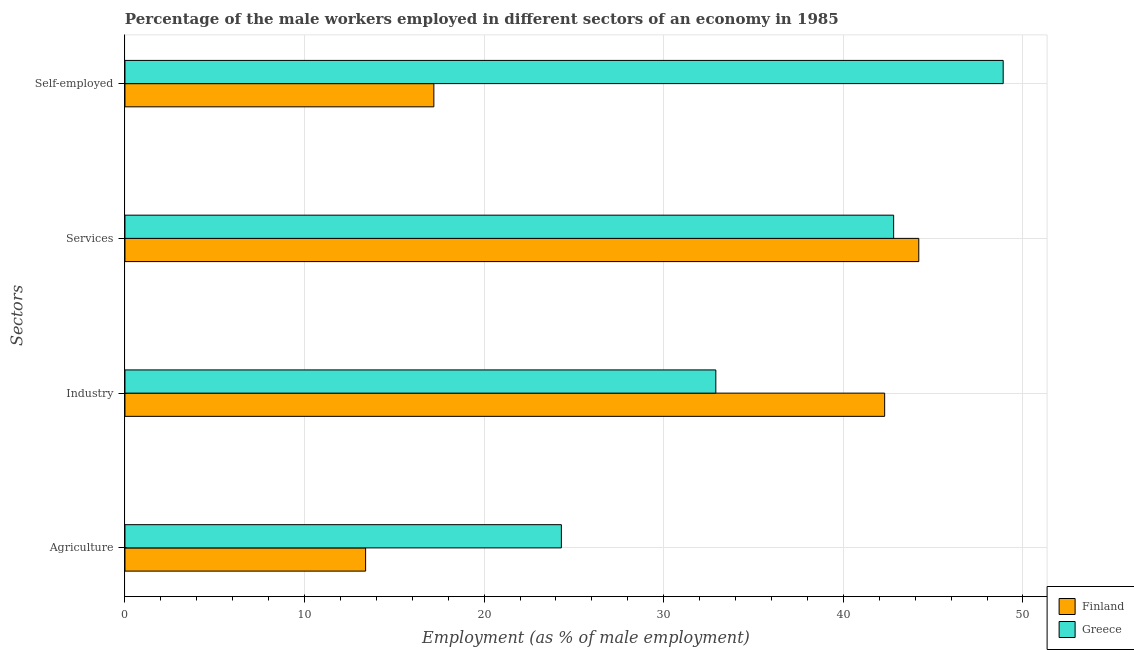How many different coloured bars are there?
Give a very brief answer. 2. Are the number of bars per tick equal to the number of legend labels?
Your answer should be very brief. Yes. Are the number of bars on each tick of the Y-axis equal?
Your response must be concise. Yes. How many bars are there on the 2nd tick from the bottom?
Your response must be concise. 2. What is the label of the 2nd group of bars from the top?
Keep it short and to the point. Services. What is the percentage of male workers in agriculture in Finland?
Offer a very short reply. 13.4. Across all countries, what is the maximum percentage of male workers in services?
Your answer should be very brief. 44.2. Across all countries, what is the minimum percentage of male workers in agriculture?
Your answer should be compact. 13.4. In which country was the percentage of self employed male workers minimum?
Provide a short and direct response. Finland. What is the total percentage of male workers in services in the graph?
Your answer should be compact. 87. What is the difference between the percentage of self employed male workers in Greece and that in Finland?
Your answer should be very brief. 31.7. What is the difference between the percentage of male workers in agriculture in Greece and the percentage of male workers in services in Finland?
Offer a very short reply. -19.9. What is the average percentage of male workers in services per country?
Make the answer very short. 43.5. What is the difference between the percentage of self employed male workers and percentage of male workers in services in Greece?
Ensure brevity in your answer.  6.1. In how many countries, is the percentage of male workers in agriculture greater than 16 %?
Your answer should be very brief. 1. What is the ratio of the percentage of male workers in agriculture in Greece to that in Finland?
Give a very brief answer. 1.81. What is the difference between the highest and the second highest percentage of self employed male workers?
Offer a very short reply. 31.7. What is the difference between the highest and the lowest percentage of male workers in services?
Offer a very short reply. 1.4. Is it the case that in every country, the sum of the percentage of male workers in agriculture and percentage of male workers in industry is greater than the percentage of male workers in services?
Ensure brevity in your answer.  Yes. Are all the bars in the graph horizontal?
Give a very brief answer. Yes. Does the graph contain any zero values?
Give a very brief answer. No. Where does the legend appear in the graph?
Your answer should be very brief. Bottom right. How are the legend labels stacked?
Provide a short and direct response. Vertical. What is the title of the graph?
Give a very brief answer. Percentage of the male workers employed in different sectors of an economy in 1985. Does "Sub-Saharan Africa (all income levels)" appear as one of the legend labels in the graph?
Make the answer very short. No. What is the label or title of the X-axis?
Provide a succinct answer. Employment (as % of male employment). What is the label or title of the Y-axis?
Make the answer very short. Sectors. What is the Employment (as % of male employment) of Finland in Agriculture?
Offer a terse response. 13.4. What is the Employment (as % of male employment) in Greece in Agriculture?
Make the answer very short. 24.3. What is the Employment (as % of male employment) of Finland in Industry?
Make the answer very short. 42.3. What is the Employment (as % of male employment) of Greece in Industry?
Provide a short and direct response. 32.9. What is the Employment (as % of male employment) in Finland in Services?
Provide a short and direct response. 44.2. What is the Employment (as % of male employment) of Greece in Services?
Offer a terse response. 42.8. What is the Employment (as % of male employment) in Finland in Self-employed?
Your response must be concise. 17.2. What is the Employment (as % of male employment) of Greece in Self-employed?
Offer a terse response. 48.9. Across all Sectors, what is the maximum Employment (as % of male employment) of Finland?
Keep it short and to the point. 44.2. Across all Sectors, what is the maximum Employment (as % of male employment) of Greece?
Ensure brevity in your answer.  48.9. Across all Sectors, what is the minimum Employment (as % of male employment) of Finland?
Make the answer very short. 13.4. Across all Sectors, what is the minimum Employment (as % of male employment) in Greece?
Provide a succinct answer. 24.3. What is the total Employment (as % of male employment) in Finland in the graph?
Give a very brief answer. 117.1. What is the total Employment (as % of male employment) of Greece in the graph?
Provide a succinct answer. 148.9. What is the difference between the Employment (as % of male employment) in Finland in Agriculture and that in Industry?
Ensure brevity in your answer.  -28.9. What is the difference between the Employment (as % of male employment) of Greece in Agriculture and that in Industry?
Give a very brief answer. -8.6. What is the difference between the Employment (as % of male employment) in Finland in Agriculture and that in Services?
Keep it short and to the point. -30.8. What is the difference between the Employment (as % of male employment) of Greece in Agriculture and that in Services?
Offer a terse response. -18.5. What is the difference between the Employment (as % of male employment) of Finland in Agriculture and that in Self-employed?
Offer a very short reply. -3.8. What is the difference between the Employment (as % of male employment) of Greece in Agriculture and that in Self-employed?
Ensure brevity in your answer.  -24.6. What is the difference between the Employment (as % of male employment) of Finland in Industry and that in Services?
Your response must be concise. -1.9. What is the difference between the Employment (as % of male employment) of Finland in Industry and that in Self-employed?
Offer a terse response. 25.1. What is the difference between the Employment (as % of male employment) of Greece in Industry and that in Self-employed?
Your answer should be very brief. -16. What is the difference between the Employment (as % of male employment) of Greece in Services and that in Self-employed?
Offer a terse response. -6.1. What is the difference between the Employment (as % of male employment) in Finland in Agriculture and the Employment (as % of male employment) in Greece in Industry?
Offer a very short reply. -19.5. What is the difference between the Employment (as % of male employment) of Finland in Agriculture and the Employment (as % of male employment) of Greece in Services?
Offer a very short reply. -29.4. What is the difference between the Employment (as % of male employment) of Finland in Agriculture and the Employment (as % of male employment) of Greece in Self-employed?
Your response must be concise. -35.5. What is the difference between the Employment (as % of male employment) in Finland in Industry and the Employment (as % of male employment) in Greece in Self-employed?
Offer a terse response. -6.6. What is the difference between the Employment (as % of male employment) of Finland in Services and the Employment (as % of male employment) of Greece in Self-employed?
Your answer should be compact. -4.7. What is the average Employment (as % of male employment) of Finland per Sectors?
Provide a succinct answer. 29.27. What is the average Employment (as % of male employment) of Greece per Sectors?
Provide a short and direct response. 37.23. What is the difference between the Employment (as % of male employment) in Finland and Employment (as % of male employment) in Greece in Services?
Your answer should be very brief. 1.4. What is the difference between the Employment (as % of male employment) of Finland and Employment (as % of male employment) of Greece in Self-employed?
Make the answer very short. -31.7. What is the ratio of the Employment (as % of male employment) in Finland in Agriculture to that in Industry?
Provide a short and direct response. 0.32. What is the ratio of the Employment (as % of male employment) in Greece in Agriculture to that in Industry?
Make the answer very short. 0.74. What is the ratio of the Employment (as % of male employment) of Finland in Agriculture to that in Services?
Your response must be concise. 0.3. What is the ratio of the Employment (as % of male employment) in Greece in Agriculture to that in Services?
Ensure brevity in your answer.  0.57. What is the ratio of the Employment (as % of male employment) of Finland in Agriculture to that in Self-employed?
Give a very brief answer. 0.78. What is the ratio of the Employment (as % of male employment) of Greece in Agriculture to that in Self-employed?
Your answer should be very brief. 0.5. What is the ratio of the Employment (as % of male employment) in Greece in Industry to that in Services?
Keep it short and to the point. 0.77. What is the ratio of the Employment (as % of male employment) in Finland in Industry to that in Self-employed?
Ensure brevity in your answer.  2.46. What is the ratio of the Employment (as % of male employment) of Greece in Industry to that in Self-employed?
Offer a terse response. 0.67. What is the ratio of the Employment (as % of male employment) in Finland in Services to that in Self-employed?
Provide a short and direct response. 2.57. What is the ratio of the Employment (as % of male employment) of Greece in Services to that in Self-employed?
Offer a terse response. 0.88. What is the difference between the highest and the second highest Employment (as % of male employment) of Finland?
Your answer should be compact. 1.9. What is the difference between the highest and the second highest Employment (as % of male employment) of Greece?
Offer a very short reply. 6.1. What is the difference between the highest and the lowest Employment (as % of male employment) in Finland?
Offer a terse response. 30.8. What is the difference between the highest and the lowest Employment (as % of male employment) of Greece?
Make the answer very short. 24.6. 